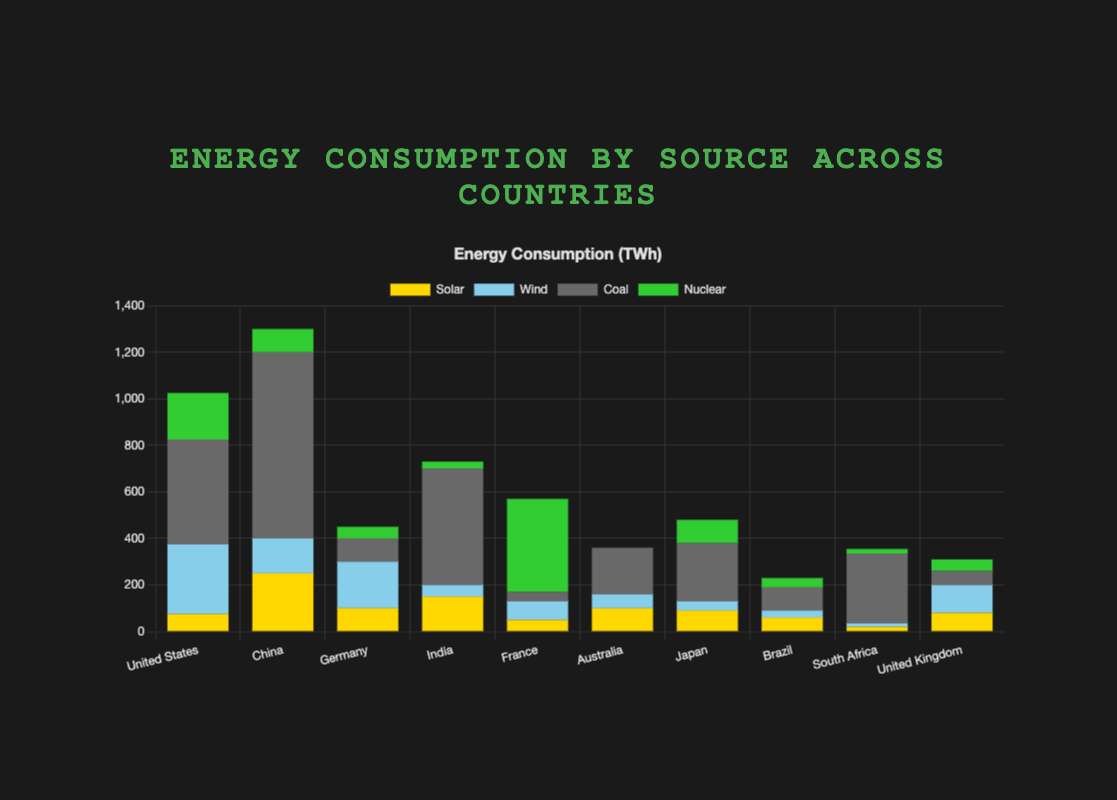Which country relies most on coal for its energy consumption? From the stacked bar chart, look for the country with the tallest dark gray (Coal) segment. The length of the Coal segment for China is the longest, indicating the highest reliance on coal.
Answer: China What is the total energy consumption for India? To find the total energy consumption, sum all energy sources for India: Solar (150) + Wind (50) + Coal (500) + Nuclear (30). Thus, the total is 150 + 50 + 500 + 30 = 730 TWh.
Answer: 730 TWh How does Germany's solar energy consumption compare to Australia's? Compare the lengths of the yellow (Solar) segments for Germany and Australia. Germany (100) has a taller Solar segment than Australia (100), meaning their Solar consumption is equal.
Answer: Equal Which country has no nuclear energy consumption? Look for the country with no green (Nuclear) segment in the stacked bar. Only Australia has no green segment, indicating zero nuclear energy consumption.
Answer: Australia What is the total energy consumption for Brazil and South Africa combined? Sum all energy sources for both countries. Brazil: Solar (60) + Wind (30) + Coal (100) + Nuclear (40) = 230 TWh. South Africa: Solar (20) + Wind (15) + Coal (300) + Nuclear (20) = 355 TWh. The combined total is 230 + 355 = 585 TWh.
Answer: 585 TWh Which country has the smallest contribution of wind energy in its mix? Inspect the light blue (Wind) segments for each country. South Africa's Wind segment (15 TWh) is the shortest, indicating the least wind energy contribution.
Answer: South Africa Is the solar energy consumption of China greater than the combined solar energy consumption of Germany and the United Kingdom? Compare China's Solar (250 TWh) with the combined Solar of Germany (100 TWh) and the United Kingdom (80 TWh): 250 vs. 100 + 80 = 180. China's Solar consumption is greater.
Answer: Yes Which country has the largest proportion of nuclear energy in its total energy consumption? Determine the country with the longest green (Nuclear) segment relative to its total bar height. France’s Nuclear segment is very prominent relative to its total consumption, indicating a high proportion.
Answer: France What percentage of the United States' energy consumption is Wind energy? Calculate the proportion of Wind energy in the United States by dividing Wind (300) by the total energy consumption (75 + 300 + 450 + 200 = 1025). Then multiply by 100. (300/1025) * 100 ≈ 29.27%.
Answer: ~29.27% Compare the coal energy consumption between France and Japan. Compare the lengths of the dark gray (Coal) segments for France (40) and Japan (250). Japan's Coal segment is significantly larger, indicating greater consumption.
Answer: Japan 